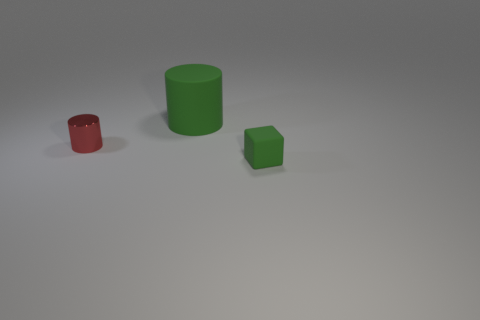Add 1 metallic cylinders. How many objects exist? 4 Subtract all cylinders. How many objects are left? 1 Add 2 tiny green matte blocks. How many tiny green matte blocks are left? 3 Add 3 green matte objects. How many green matte objects exist? 5 Subtract 0 gray blocks. How many objects are left? 3 Subtract all blue spheres. Subtract all tiny green rubber cubes. How many objects are left? 2 